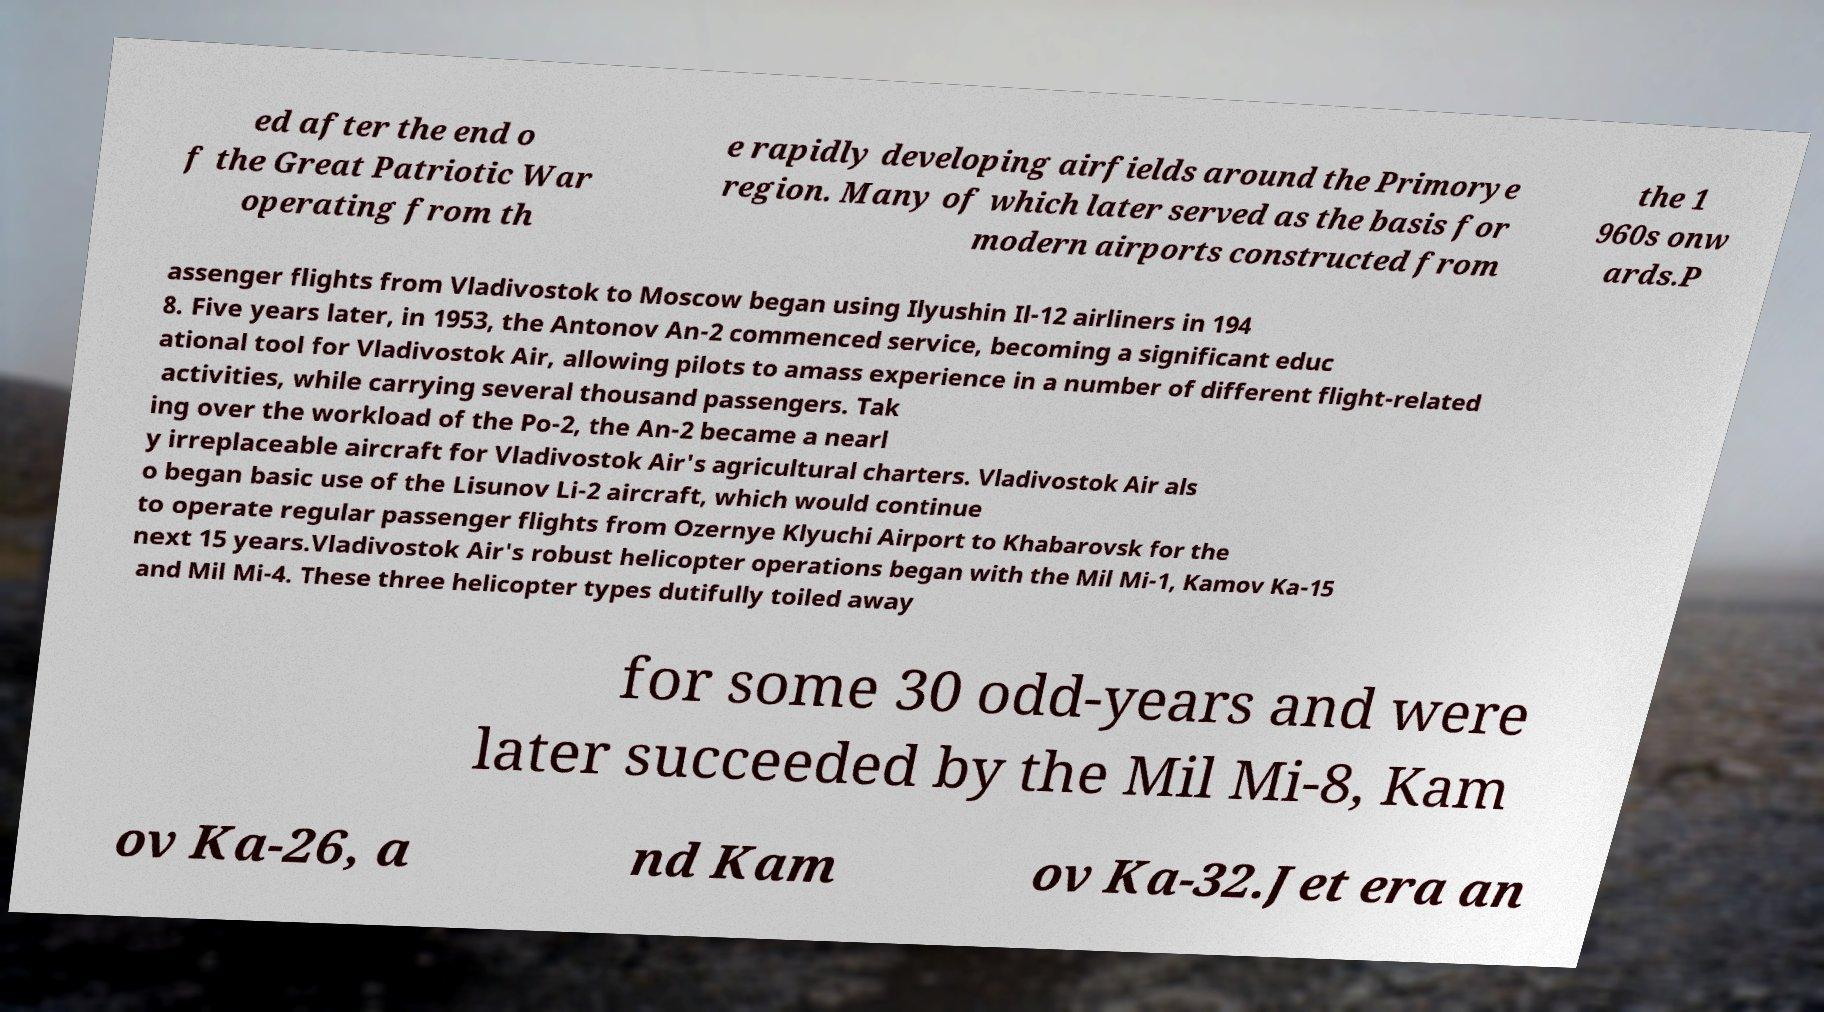Can you read and provide the text displayed in the image?This photo seems to have some interesting text. Can you extract and type it out for me? ed after the end o f the Great Patriotic War operating from th e rapidly developing airfields around the Primorye region. Many of which later served as the basis for modern airports constructed from the 1 960s onw ards.P assenger flights from Vladivostok to Moscow began using Ilyushin Il-12 airliners in 194 8. Five years later, in 1953, the Antonov An-2 commenced service, becoming a significant educ ational tool for Vladivostok Air, allowing pilots to amass experience in a number of different flight-related activities, while carrying several thousand passengers. Tak ing over the workload of the Po-2, the An-2 became a nearl y irreplaceable aircraft for Vladivostok Air's agricultural charters. Vladivostok Air als o began basic use of the Lisunov Li-2 aircraft, which would continue to operate regular passenger flights from Ozernye Klyuchi Airport to Khabarovsk for the next 15 years.Vladivostok Air's robust helicopter operations began with the Mil Mi-1, Kamov Ka-15 and Mil Mi-4. These three helicopter types dutifully toiled away for some 30 odd-years and were later succeeded by the Mil Mi-8, Kam ov Ka-26, a nd Kam ov Ka-32.Jet era an 